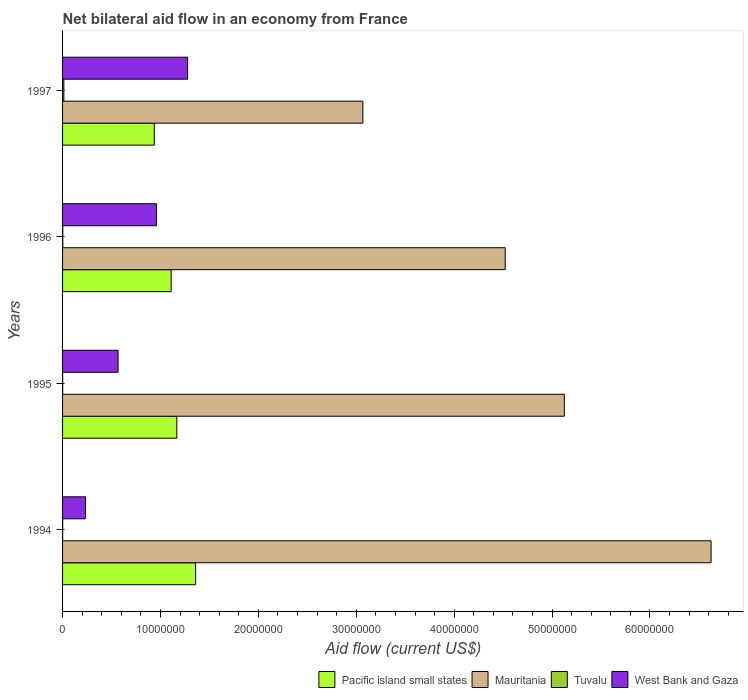Are the number of bars on each tick of the Y-axis equal?
Provide a succinct answer. Yes. How many bars are there on the 1st tick from the top?
Provide a short and direct response. 4. How many bars are there on the 2nd tick from the bottom?
Your answer should be very brief. 4. What is the label of the 4th group of bars from the top?
Your answer should be compact. 1994. In how many cases, is the number of bars for a given year not equal to the number of legend labels?
Offer a terse response. 0. What is the net bilateral aid flow in Pacific island small states in 1995?
Give a very brief answer. 1.17e+07. Across all years, what is the maximum net bilateral aid flow in West Bank and Gaza?
Offer a terse response. 1.28e+07. Across all years, what is the minimum net bilateral aid flow in Pacific island small states?
Offer a terse response. 9.37e+06. In which year was the net bilateral aid flow in West Bank and Gaza maximum?
Provide a short and direct response. 1997. What is the total net bilateral aid flow in Tuvalu in the graph?
Your answer should be very brief. 1.70e+05. What is the difference between the net bilateral aid flow in Tuvalu in 1994 and that in 1997?
Your answer should be very brief. -1.20e+05. What is the difference between the net bilateral aid flow in Tuvalu in 1994 and the net bilateral aid flow in West Bank and Gaza in 1995?
Your response must be concise. -5.66e+06. What is the average net bilateral aid flow in Pacific island small states per year?
Offer a terse response. 1.14e+07. In the year 1997, what is the difference between the net bilateral aid flow in Pacific island small states and net bilateral aid flow in West Bank and Gaza?
Your answer should be compact. -3.40e+06. In how many years, is the net bilateral aid flow in West Bank and Gaza greater than 36000000 US$?
Your answer should be very brief. 0. What is the ratio of the net bilateral aid flow in Mauritania in 1995 to that in 1996?
Ensure brevity in your answer.  1.13. What is the difference between the highest and the second highest net bilateral aid flow in Mauritania?
Provide a short and direct response. 1.50e+07. In how many years, is the net bilateral aid flow in West Bank and Gaza greater than the average net bilateral aid flow in West Bank and Gaza taken over all years?
Provide a short and direct response. 2. Is the sum of the net bilateral aid flow in Pacific island small states in 1994 and 1996 greater than the maximum net bilateral aid flow in Mauritania across all years?
Offer a very short reply. No. What does the 4th bar from the top in 1997 represents?
Your answer should be very brief. Pacific island small states. What does the 3rd bar from the bottom in 1995 represents?
Make the answer very short. Tuvalu. Is it the case that in every year, the sum of the net bilateral aid flow in Mauritania and net bilateral aid flow in Tuvalu is greater than the net bilateral aid flow in West Bank and Gaza?
Keep it short and to the point. Yes. How many bars are there?
Make the answer very short. 16. Are all the bars in the graph horizontal?
Provide a short and direct response. Yes. How many years are there in the graph?
Provide a succinct answer. 4. What is the difference between two consecutive major ticks on the X-axis?
Provide a succinct answer. 1.00e+07. Does the graph contain any zero values?
Give a very brief answer. No. How many legend labels are there?
Make the answer very short. 4. What is the title of the graph?
Your answer should be very brief. Net bilateral aid flow in an economy from France. What is the label or title of the Y-axis?
Your response must be concise. Years. What is the Aid flow (current US$) of Pacific island small states in 1994?
Offer a very short reply. 1.36e+07. What is the Aid flow (current US$) in Mauritania in 1994?
Give a very brief answer. 6.62e+07. What is the Aid flow (current US$) in Tuvalu in 1994?
Provide a succinct answer. 10000. What is the Aid flow (current US$) of West Bank and Gaza in 1994?
Offer a very short reply. 2.34e+06. What is the Aid flow (current US$) in Pacific island small states in 1995?
Your answer should be compact. 1.17e+07. What is the Aid flow (current US$) of Mauritania in 1995?
Ensure brevity in your answer.  5.12e+07. What is the Aid flow (current US$) of Tuvalu in 1995?
Give a very brief answer. 10000. What is the Aid flow (current US$) of West Bank and Gaza in 1995?
Provide a succinct answer. 5.67e+06. What is the Aid flow (current US$) of Pacific island small states in 1996?
Make the answer very short. 1.11e+07. What is the Aid flow (current US$) in Mauritania in 1996?
Ensure brevity in your answer.  4.52e+07. What is the Aid flow (current US$) of Tuvalu in 1996?
Offer a terse response. 2.00e+04. What is the Aid flow (current US$) in West Bank and Gaza in 1996?
Ensure brevity in your answer.  9.59e+06. What is the Aid flow (current US$) in Pacific island small states in 1997?
Your response must be concise. 9.37e+06. What is the Aid flow (current US$) of Mauritania in 1997?
Offer a very short reply. 3.07e+07. What is the Aid flow (current US$) in West Bank and Gaza in 1997?
Your answer should be compact. 1.28e+07. Across all years, what is the maximum Aid flow (current US$) in Pacific island small states?
Provide a succinct answer. 1.36e+07. Across all years, what is the maximum Aid flow (current US$) of Mauritania?
Keep it short and to the point. 6.62e+07. Across all years, what is the maximum Aid flow (current US$) of Tuvalu?
Give a very brief answer. 1.30e+05. Across all years, what is the maximum Aid flow (current US$) in West Bank and Gaza?
Offer a terse response. 1.28e+07. Across all years, what is the minimum Aid flow (current US$) in Pacific island small states?
Your response must be concise. 9.37e+06. Across all years, what is the minimum Aid flow (current US$) in Mauritania?
Your answer should be compact. 3.07e+07. Across all years, what is the minimum Aid flow (current US$) of West Bank and Gaza?
Ensure brevity in your answer.  2.34e+06. What is the total Aid flow (current US$) in Pacific island small states in the graph?
Provide a succinct answer. 4.57e+07. What is the total Aid flow (current US$) in Mauritania in the graph?
Your answer should be very brief. 1.93e+08. What is the total Aid flow (current US$) in West Bank and Gaza in the graph?
Provide a short and direct response. 3.04e+07. What is the difference between the Aid flow (current US$) in Pacific island small states in 1994 and that in 1995?
Offer a very short reply. 1.92e+06. What is the difference between the Aid flow (current US$) of Mauritania in 1994 and that in 1995?
Make the answer very short. 1.50e+07. What is the difference between the Aid flow (current US$) in West Bank and Gaza in 1994 and that in 1995?
Your response must be concise. -3.33e+06. What is the difference between the Aid flow (current US$) in Pacific island small states in 1994 and that in 1996?
Offer a very short reply. 2.50e+06. What is the difference between the Aid flow (current US$) in Mauritania in 1994 and that in 1996?
Keep it short and to the point. 2.10e+07. What is the difference between the Aid flow (current US$) in Tuvalu in 1994 and that in 1996?
Keep it short and to the point. -10000. What is the difference between the Aid flow (current US$) of West Bank and Gaza in 1994 and that in 1996?
Offer a terse response. -7.25e+06. What is the difference between the Aid flow (current US$) of Pacific island small states in 1994 and that in 1997?
Provide a succinct answer. 4.22e+06. What is the difference between the Aid flow (current US$) of Mauritania in 1994 and that in 1997?
Offer a very short reply. 3.56e+07. What is the difference between the Aid flow (current US$) of Tuvalu in 1994 and that in 1997?
Offer a very short reply. -1.20e+05. What is the difference between the Aid flow (current US$) of West Bank and Gaza in 1994 and that in 1997?
Offer a terse response. -1.04e+07. What is the difference between the Aid flow (current US$) of Pacific island small states in 1995 and that in 1996?
Ensure brevity in your answer.  5.80e+05. What is the difference between the Aid flow (current US$) in Mauritania in 1995 and that in 1996?
Keep it short and to the point. 6.04e+06. What is the difference between the Aid flow (current US$) in West Bank and Gaza in 1995 and that in 1996?
Your answer should be very brief. -3.92e+06. What is the difference between the Aid flow (current US$) in Pacific island small states in 1995 and that in 1997?
Keep it short and to the point. 2.30e+06. What is the difference between the Aid flow (current US$) of Mauritania in 1995 and that in 1997?
Give a very brief answer. 2.06e+07. What is the difference between the Aid flow (current US$) in Tuvalu in 1995 and that in 1997?
Ensure brevity in your answer.  -1.20e+05. What is the difference between the Aid flow (current US$) of West Bank and Gaza in 1995 and that in 1997?
Your answer should be compact. -7.10e+06. What is the difference between the Aid flow (current US$) of Pacific island small states in 1996 and that in 1997?
Keep it short and to the point. 1.72e+06. What is the difference between the Aid flow (current US$) of Mauritania in 1996 and that in 1997?
Provide a short and direct response. 1.45e+07. What is the difference between the Aid flow (current US$) in Tuvalu in 1996 and that in 1997?
Your response must be concise. -1.10e+05. What is the difference between the Aid flow (current US$) in West Bank and Gaza in 1996 and that in 1997?
Make the answer very short. -3.18e+06. What is the difference between the Aid flow (current US$) of Pacific island small states in 1994 and the Aid flow (current US$) of Mauritania in 1995?
Ensure brevity in your answer.  -3.77e+07. What is the difference between the Aid flow (current US$) in Pacific island small states in 1994 and the Aid flow (current US$) in Tuvalu in 1995?
Provide a succinct answer. 1.36e+07. What is the difference between the Aid flow (current US$) in Pacific island small states in 1994 and the Aid flow (current US$) in West Bank and Gaza in 1995?
Provide a succinct answer. 7.92e+06. What is the difference between the Aid flow (current US$) in Mauritania in 1994 and the Aid flow (current US$) in Tuvalu in 1995?
Offer a very short reply. 6.62e+07. What is the difference between the Aid flow (current US$) in Mauritania in 1994 and the Aid flow (current US$) in West Bank and Gaza in 1995?
Your answer should be compact. 6.06e+07. What is the difference between the Aid flow (current US$) in Tuvalu in 1994 and the Aid flow (current US$) in West Bank and Gaza in 1995?
Provide a short and direct response. -5.66e+06. What is the difference between the Aid flow (current US$) of Pacific island small states in 1994 and the Aid flow (current US$) of Mauritania in 1996?
Offer a very short reply. -3.16e+07. What is the difference between the Aid flow (current US$) of Pacific island small states in 1994 and the Aid flow (current US$) of Tuvalu in 1996?
Ensure brevity in your answer.  1.36e+07. What is the difference between the Aid flow (current US$) in Mauritania in 1994 and the Aid flow (current US$) in Tuvalu in 1996?
Ensure brevity in your answer.  6.62e+07. What is the difference between the Aid flow (current US$) of Mauritania in 1994 and the Aid flow (current US$) of West Bank and Gaza in 1996?
Your answer should be compact. 5.66e+07. What is the difference between the Aid flow (current US$) of Tuvalu in 1994 and the Aid flow (current US$) of West Bank and Gaza in 1996?
Provide a succinct answer. -9.58e+06. What is the difference between the Aid flow (current US$) in Pacific island small states in 1994 and the Aid flow (current US$) in Mauritania in 1997?
Keep it short and to the point. -1.71e+07. What is the difference between the Aid flow (current US$) in Pacific island small states in 1994 and the Aid flow (current US$) in Tuvalu in 1997?
Provide a short and direct response. 1.35e+07. What is the difference between the Aid flow (current US$) of Pacific island small states in 1994 and the Aid flow (current US$) of West Bank and Gaza in 1997?
Your response must be concise. 8.20e+05. What is the difference between the Aid flow (current US$) in Mauritania in 1994 and the Aid flow (current US$) in Tuvalu in 1997?
Offer a terse response. 6.61e+07. What is the difference between the Aid flow (current US$) of Mauritania in 1994 and the Aid flow (current US$) of West Bank and Gaza in 1997?
Provide a short and direct response. 5.35e+07. What is the difference between the Aid flow (current US$) in Tuvalu in 1994 and the Aid flow (current US$) in West Bank and Gaza in 1997?
Provide a succinct answer. -1.28e+07. What is the difference between the Aid flow (current US$) of Pacific island small states in 1995 and the Aid flow (current US$) of Mauritania in 1996?
Your response must be concise. -3.35e+07. What is the difference between the Aid flow (current US$) in Pacific island small states in 1995 and the Aid flow (current US$) in Tuvalu in 1996?
Give a very brief answer. 1.16e+07. What is the difference between the Aid flow (current US$) in Pacific island small states in 1995 and the Aid flow (current US$) in West Bank and Gaza in 1996?
Your response must be concise. 2.08e+06. What is the difference between the Aid flow (current US$) in Mauritania in 1995 and the Aid flow (current US$) in Tuvalu in 1996?
Offer a terse response. 5.12e+07. What is the difference between the Aid flow (current US$) in Mauritania in 1995 and the Aid flow (current US$) in West Bank and Gaza in 1996?
Make the answer very short. 4.17e+07. What is the difference between the Aid flow (current US$) of Tuvalu in 1995 and the Aid flow (current US$) of West Bank and Gaza in 1996?
Offer a terse response. -9.58e+06. What is the difference between the Aid flow (current US$) in Pacific island small states in 1995 and the Aid flow (current US$) in Mauritania in 1997?
Make the answer very short. -1.90e+07. What is the difference between the Aid flow (current US$) in Pacific island small states in 1995 and the Aid flow (current US$) in Tuvalu in 1997?
Keep it short and to the point. 1.15e+07. What is the difference between the Aid flow (current US$) of Pacific island small states in 1995 and the Aid flow (current US$) of West Bank and Gaza in 1997?
Offer a very short reply. -1.10e+06. What is the difference between the Aid flow (current US$) in Mauritania in 1995 and the Aid flow (current US$) in Tuvalu in 1997?
Provide a succinct answer. 5.11e+07. What is the difference between the Aid flow (current US$) of Mauritania in 1995 and the Aid flow (current US$) of West Bank and Gaza in 1997?
Keep it short and to the point. 3.85e+07. What is the difference between the Aid flow (current US$) of Tuvalu in 1995 and the Aid flow (current US$) of West Bank and Gaza in 1997?
Your response must be concise. -1.28e+07. What is the difference between the Aid flow (current US$) in Pacific island small states in 1996 and the Aid flow (current US$) in Mauritania in 1997?
Your response must be concise. -1.96e+07. What is the difference between the Aid flow (current US$) of Pacific island small states in 1996 and the Aid flow (current US$) of Tuvalu in 1997?
Make the answer very short. 1.10e+07. What is the difference between the Aid flow (current US$) of Pacific island small states in 1996 and the Aid flow (current US$) of West Bank and Gaza in 1997?
Offer a terse response. -1.68e+06. What is the difference between the Aid flow (current US$) in Mauritania in 1996 and the Aid flow (current US$) in Tuvalu in 1997?
Provide a succinct answer. 4.51e+07. What is the difference between the Aid flow (current US$) of Mauritania in 1996 and the Aid flow (current US$) of West Bank and Gaza in 1997?
Your response must be concise. 3.24e+07. What is the difference between the Aid flow (current US$) in Tuvalu in 1996 and the Aid flow (current US$) in West Bank and Gaza in 1997?
Ensure brevity in your answer.  -1.28e+07. What is the average Aid flow (current US$) of Pacific island small states per year?
Your answer should be compact. 1.14e+07. What is the average Aid flow (current US$) of Mauritania per year?
Give a very brief answer. 4.83e+07. What is the average Aid flow (current US$) in Tuvalu per year?
Give a very brief answer. 4.25e+04. What is the average Aid flow (current US$) of West Bank and Gaza per year?
Offer a very short reply. 7.59e+06. In the year 1994, what is the difference between the Aid flow (current US$) in Pacific island small states and Aid flow (current US$) in Mauritania?
Your answer should be very brief. -5.26e+07. In the year 1994, what is the difference between the Aid flow (current US$) of Pacific island small states and Aid flow (current US$) of Tuvalu?
Offer a very short reply. 1.36e+07. In the year 1994, what is the difference between the Aid flow (current US$) of Pacific island small states and Aid flow (current US$) of West Bank and Gaza?
Make the answer very short. 1.12e+07. In the year 1994, what is the difference between the Aid flow (current US$) in Mauritania and Aid flow (current US$) in Tuvalu?
Make the answer very short. 6.62e+07. In the year 1994, what is the difference between the Aid flow (current US$) in Mauritania and Aid flow (current US$) in West Bank and Gaza?
Ensure brevity in your answer.  6.39e+07. In the year 1994, what is the difference between the Aid flow (current US$) of Tuvalu and Aid flow (current US$) of West Bank and Gaza?
Ensure brevity in your answer.  -2.33e+06. In the year 1995, what is the difference between the Aid flow (current US$) of Pacific island small states and Aid flow (current US$) of Mauritania?
Make the answer very short. -3.96e+07. In the year 1995, what is the difference between the Aid flow (current US$) in Pacific island small states and Aid flow (current US$) in Tuvalu?
Keep it short and to the point. 1.17e+07. In the year 1995, what is the difference between the Aid flow (current US$) in Pacific island small states and Aid flow (current US$) in West Bank and Gaza?
Provide a short and direct response. 6.00e+06. In the year 1995, what is the difference between the Aid flow (current US$) of Mauritania and Aid flow (current US$) of Tuvalu?
Offer a very short reply. 5.12e+07. In the year 1995, what is the difference between the Aid flow (current US$) in Mauritania and Aid flow (current US$) in West Bank and Gaza?
Provide a short and direct response. 4.56e+07. In the year 1995, what is the difference between the Aid flow (current US$) in Tuvalu and Aid flow (current US$) in West Bank and Gaza?
Ensure brevity in your answer.  -5.66e+06. In the year 1996, what is the difference between the Aid flow (current US$) in Pacific island small states and Aid flow (current US$) in Mauritania?
Offer a terse response. -3.41e+07. In the year 1996, what is the difference between the Aid flow (current US$) of Pacific island small states and Aid flow (current US$) of Tuvalu?
Your answer should be very brief. 1.11e+07. In the year 1996, what is the difference between the Aid flow (current US$) of Pacific island small states and Aid flow (current US$) of West Bank and Gaza?
Make the answer very short. 1.50e+06. In the year 1996, what is the difference between the Aid flow (current US$) in Mauritania and Aid flow (current US$) in Tuvalu?
Your answer should be compact. 4.52e+07. In the year 1996, what is the difference between the Aid flow (current US$) in Mauritania and Aid flow (current US$) in West Bank and Gaza?
Ensure brevity in your answer.  3.56e+07. In the year 1996, what is the difference between the Aid flow (current US$) in Tuvalu and Aid flow (current US$) in West Bank and Gaza?
Make the answer very short. -9.57e+06. In the year 1997, what is the difference between the Aid flow (current US$) in Pacific island small states and Aid flow (current US$) in Mauritania?
Provide a succinct answer. -2.13e+07. In the year 1997, what is the difference between the Aid flow (current US$) in Pacific island small states and Aid flow (current US$) in Tuvalu?
Make the answer very short. 9.24e+06. In the year 1997, what is the difference between the Aid flow (current US$) in Pacific island small states and Aid flow (current US$) in West Bank and Gaza?
Your answer should be compact. -3.40e+06. In the year 1997, what is the difference between the Aid flow (current US$) of Mauritania and Aid flow (current US$) of Tuvalu?
Give a very brief answer. 3.05e+07. In the year 1997, what is the difference between the Aid flow (current US$) in Mauritania and Aid flow (current US$) in West Bank and Gaza?
Provide a short and direct response. 1.79e+07. In the year 1997, what is the difference between the Aid flow (current US$) in Tuvalu and Aid flow (current US$) in West Bank and Gaza?
Offer a terse response. -1.26e+07. What is the ratio of the Aid flow (current US$) of Pacific island small states in 1994 to that in 1995?
Your answer should be compact. 1.16. What is the ratio of the Aid flow (current US$) in Mauritania in 1994 to that in 1995?
Your answer should be compact. 1.29. What is the ratio of the Aid flow (current US$) in Tuvalu in 1994 to that in 1995?
Your answer should be very brief. 1. What is the ratio of the Aid flow (current US$) in West Bank and Gaza in 1994 to that in 1995?
Your response must be concise. 0.41. What is the ratio of the Aid flow (current US$) of Pacific island small states in 1994 to that in 1996?
Your response must be concise. 1.23. What is the ratio of the Aid flow (current US$) of Mauritania in 1994 to that in 1996?
Offer a terse response. 1.47. What is the ratio of the Aid flow (current US$) in West Bank and Gaza in 1994 to that in 1996?
Provide a succinct answer. 0.24. What is the ratio of the Aid flow (current US$) of Pacific island small states in 1994 to that in 1997?
Give a very brief answer. 1.45. What is the ratio of the Aid flow (current US$) of Mauritania in 1994 to that in 1997?
Your answer should be very brief. 2.16. What is the ratio of the Aid flow (current US$) in Tuvalu in 1994 to that in 1997?
Your answer should be very brief. 0.08. What is the ratio of the Aid flow (current US$) in West Bank and Gaza in 1994 to that in 1997?
Ensure brevity in your answer.  0.18. What is the ratio of the Aid flow (current US$) of Pacific island small states in 1995 to that in 1996?
Make the answer very short. 1.05. What is the ratio of the Aid flow (current US$) of Mauritania in 1995 to that in 1996?
Offer a terse response. 1.13. What is the ratio of the Aid flow (current US$) of Tuvalu in 1995 to that in 1996?
Offer a terse response. 0.5. What is the ratio of the Aid flow (current US$) in West Bank and Gaza in 1995 to that in 1996?
Ensure brevity in your answer.  0.59. What is the ratio of the Aid flow (current US$) of Pacific island small states in 1995 to that in 1997?
Keep it short and to the point. 1.25. What is the ratio of the Aid flow (current US$) in Mauritania in 1995 to that in 1997?
Make the answer very short. 1.67. What is the ratio of the Aid flow (current US$) in Tuvalu in 1995 to that in 1997?
Make the answer very short. 0.08. What is the ratio of the Aid flow (current US$) in West Bank and Gaza in 1995 to that in 1997?
Your response must be concise. 0.44. What is the ratio of the Aid flow (current US$) of Pacific island small states in 1996 to that in 1997?
Make the answer very short. 1.18. What is the ratio of the Aid flow (current US$) of Mauritania in 1996 to that in 1997?
Ensure brevity in your answer.  1.47. What is the ratio of the Aid flow (current US$) in Tuvalu in 1996 to that in 1997?
Offer a terse response. 0.15. What is the ratio of the Aid flow (current US$) of West Bank and Gaza in 1996 to that in 1997?
Your answer should be very brief. 0.75. What is the difference between the highest and the second highest Aid flow (current US$) in Pacific island small states?
Your answer should be very brief. 1.92e+06. What is the difference between the highest and the second highest Aid flow (current US$) of Mauritania?
Offer a very short reply. 1.50e+07. What is the difference between the highest and the second highest Aid flow (current US$) of West Bank and Gaza?
Give a very brief answer. 3.18e+06. What is the difference between the highest and the lowest Aid flow (current US$) of Pacific island small states?
Keep it short and to the point. 4.22e+06. What is the difference between the highest and the lowest Aid flow (current US$) of Mauritania?
Offer a terse response. 3.56e+07. What is the difference between the highest and the lowest Aid flow (current US$) in Tuvalu?
Your answer should be compact. 1.20e+05. What is the difference between the highest and the lowest Aid flow (current US$) in West Bank and Gaza?
Make the answer very short. 1.04e+07. 